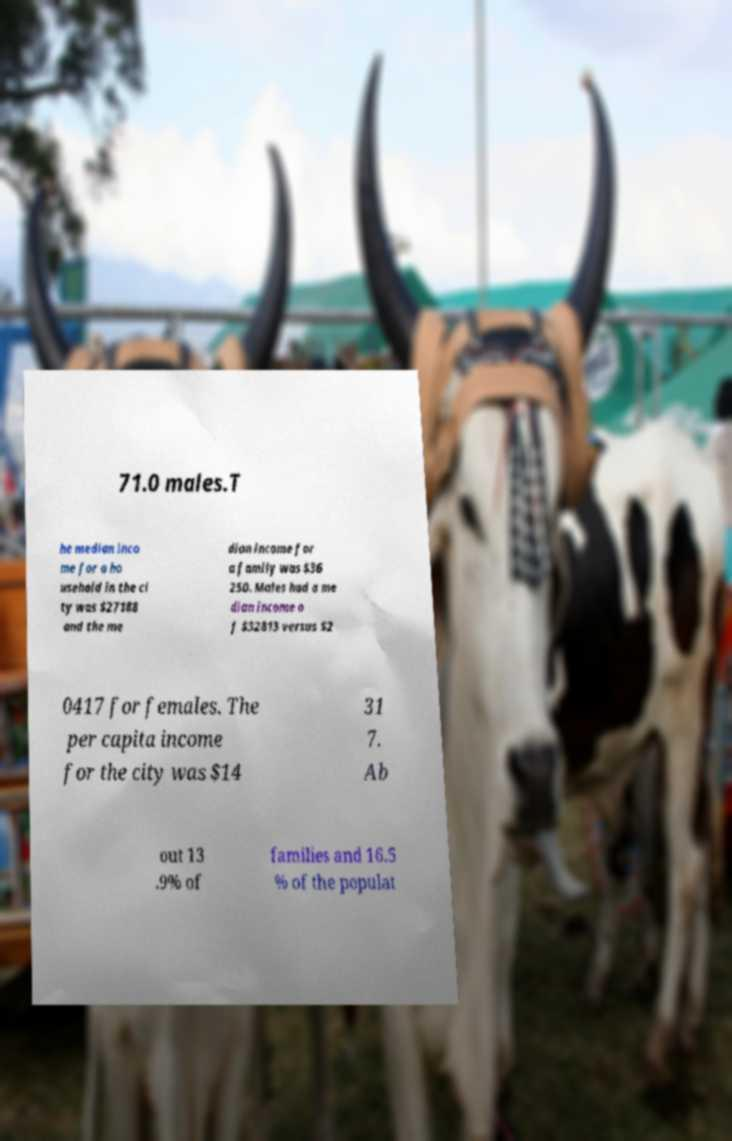What messages or text are displayed in this image? I need them in a readable, typed format. 71.0 males.T he median inco me for a ho usehold in the ci ty was $27188 and the me dian income for a family was $36 250. Males had a me dian income o f $32813 versus $2 0417 for females. The per capita income for the city was $14 31 7. Ab out 13 .9% of families and 16.5 % of the populat 